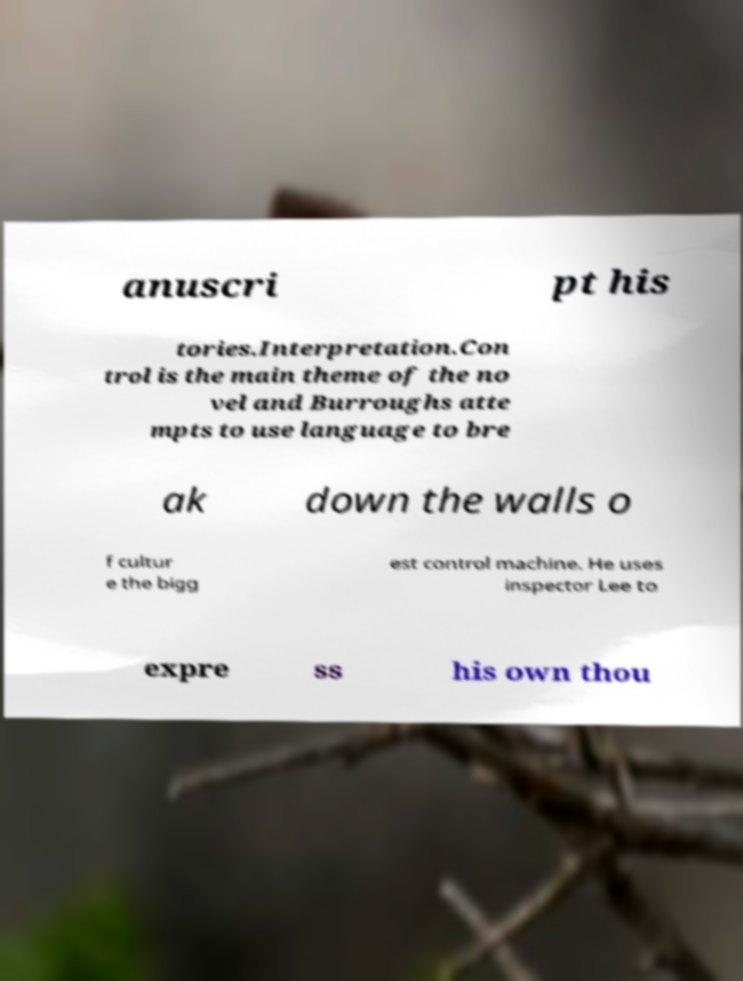Can you accurately transcribe the text from the provided image for me? anuscri pt his tories.Interpretation.Con trol is the main theme of the no vel and Burroughs atte mpts to use language to bre ak down the walls o f cultur e the bigg est control machine. He uses inspector Lee to expre ss his own thou 